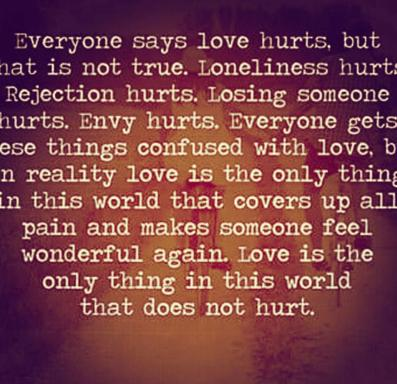How is love described in the text? Within the text, love is portrayed as an extraordinarily powerful force, capable of covering all pains and imbuing life with a renewed sense of wonder. It is the only sentiment, as per the narrative, that heals rather than hurts, setting a stark contrast against common misconceptions of love as a source of suffering. 